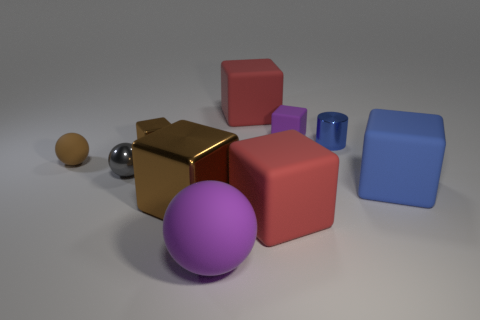Subtract all blue blocks. How many blocks are left? 5 Subtract all blue blocks. How many blocks are left? 5 Subtract all red spheres. Subtract all yellow cylinders. How many spheres are left? 3 Subtract all balls. How many objects are left? 7 Add 4 gray spheres. How many gray spheres exist? 5 Subtract 0 blue spheres. How many objects are left? 10 Subtract all cyan balls. Subtract all metal cubes. How many objects are left? 8 Add 3 large brown metal cubes. How many large brown metal cubes are left? 4 